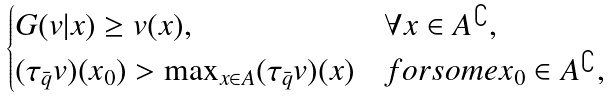Convert formula to latex. <formula><loc_0><loc_0><loc_500><loc_500>\begin{cases} G ( v | x ) \geq v ( x ) , & \forall x \in A ^ { \complement } , \\ ( \tau _ { \bar { q } } v ) ( x _ { 0 } ) > \max _ { x \in A } ( \tau _ { \bar { q } } v ) ( x ) & f o r s o m e x _ { 0 } \in A ^ { \complement } , \end{cases}</formula> 